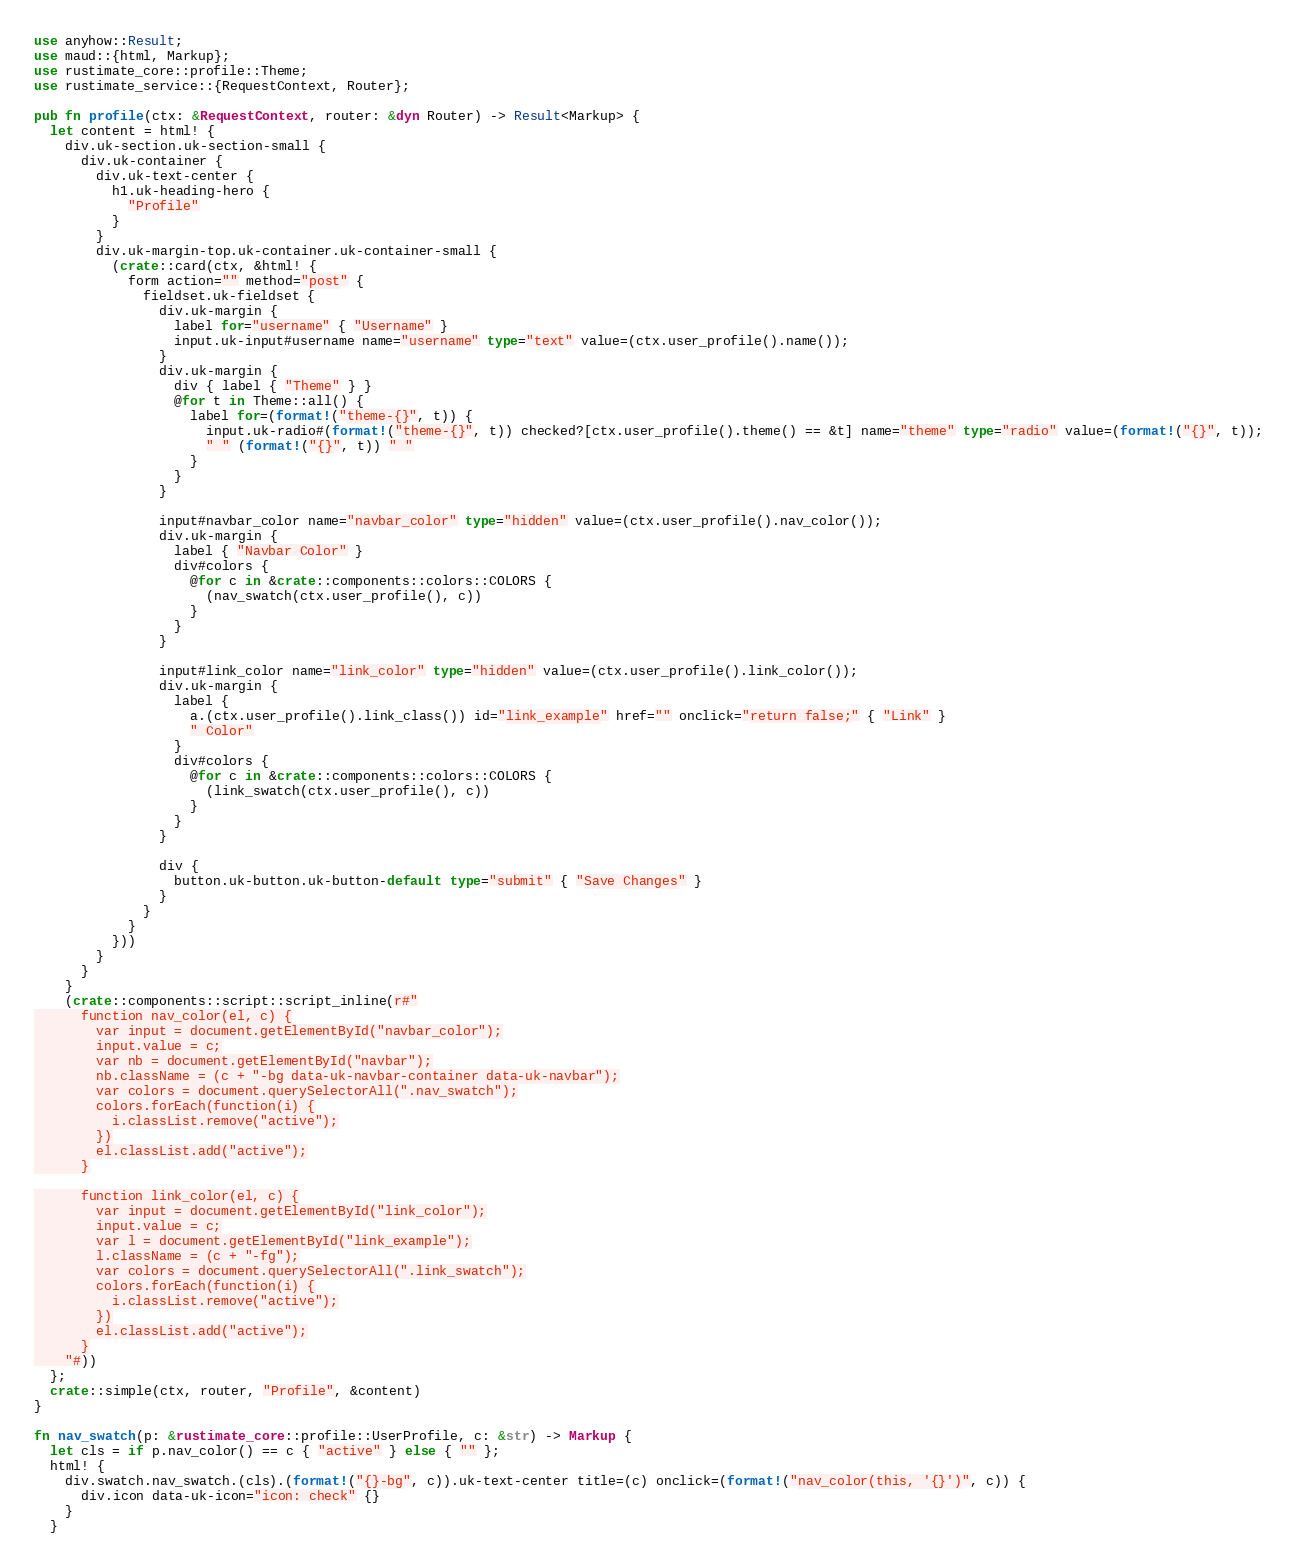Convert code to text. <code><loc_0><loc_0><loc_500><loc_500><_Rust_>use anyhow::Result;
use maud::{html, Markup};
use rustimate_core::profile::Theme;
use rustimate_service::{RequestContext, Router};

pub fn profile(ctx: &RequestContext, router: &dyn Router) -> Result<Markup> {
  let content = html! {
    div.uk-section.uk-section-small {
      div.uk-container {
        div.uk-text-center {
          h1.uk-heading-hero {
            "Profile"
          }
        }
        div.uk-margin-top.uk-container.uk-container-small {
          (crate::card(ctx, &html! {
            form action="" method="post" {
              fieldset.uk-fieldset {
                div.uk-margin {
                  label for="username" { "Username" }
                  input.uk-input#username name="username" type="text" value=(ctx.user_profile().name());
                }
                div.uk-margin {
                  div { label { "Theme" } }
                  @for t in Theme::all() {
                    label for=(format!("theme-{}", t)) {
                      input.uk-radio#(format!("theme-{}", t)) checked?[ctx.user_profile().theme() == &t] name="theme" type="radio" value=(format!("{}", t));
                      " " (format!("{}", t)) " "
                    }
                  }
                }

                input#navbar_color name="navbar_color" type="hidden" value=(ctx.user_profile().nav_color());
                div.uk-margin {
                  label { "Navbar Color" }
                  div#colors {
                    @for c in &crate::components::colors::COLORS {
                      (nav_swatch(ctx.user_profile(), c))
                    }
                  }
                }

                input#link_color name="link_color" type="hidden" value=(ctx.user_profile().link_color());
                div.uk-margin {
                  label {
                    a.(ctx.user_profile().link_class()) id="link_example" href="" onclick="return false;" { "Link" }
                    " Color"
                  }
                  div#colors {
                    @for c in &crate::components::colors::COLORS {
                      (link_swatch(ctx.user_profile(), c))
                    }
                  }
                }

                div {
                  button.uk-button.uk-button-default type="submit" { "Save Changes" }
                }
              }
            }
          }))
        }
      }
    }
    (crate::components::script::script_inline(r#"
      function nav_color(el, c) {
        var input = document.getElementById("navbar_color");
        input.value = c;
        var nb = document.getElementById("navbar");
        nb.className = (c + "-bg data-uk-navbar-container data-uk-navbar");
        var colors = document.querySelectorAll(".nav_swatch");
        colors.forEach(function(i) {
          i.classList.remove("active");
        })
        el.classList.add("active");
      }

      function link_color(el, c) {
        var input = document.getElementById("link_color");
        input.value = c;
        var l = document.getElementById("link_example");
        l.className = (c + "-fg");
        var colors = document.querySelectorAll(".link_swatch");
        colors.forEach(function(i) {
          i.classList.remove("active");
        })
        el.classList.add("active");
      }
    "#))
  };
  crate::simple(ctx, router, "Profile", &content)
}

fn nav_swatch(p: &rustimate_core::profile::UserProfile, c: &str) -> Markup {
  let cls = if p.nav_color() == c { "active" } else { "" };
  html! {
    div.swatch.nav_swatch.(cls).(format!("{}-bg", c)).uk-text-center title=(c) onclick=(format!("nav_color(this, '{}')", c)) {
      div.icon data-uk-icon="icon: check" {}
    }
  }</code> 